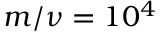Convert formula to latex. <formula><loc_0><loc_0><loc_500><loc_500>m / \nu = 1 0 ^ { 4 }</formula> 